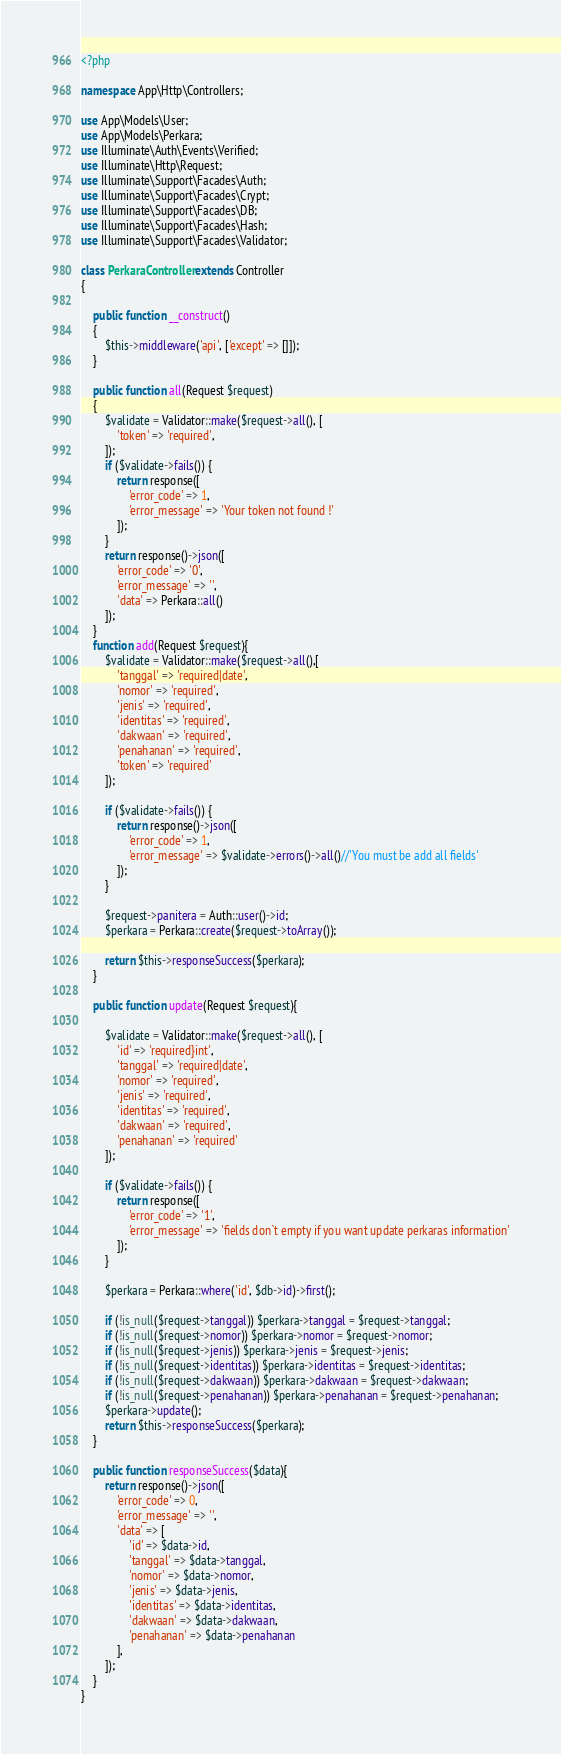Convert code to text. <code><loc_0><loc_0><loc_500><loc_500><_PHP_><?php

namespace App\Http\Controllers;

use App\Models\User;
use App\Models\Perkara;
use Illuminate\Auth\Events\Verified;
use Illuminate\Http\Request;
use Illuminate\Support\Facades\Auth;
use Illuminate\Support\Facades\Crypt;
use Illuminate\Support\Facades\DB;
use Illuminate\Support\Facades\Hash;
use Illuminate\Support\Facades\Validator;

class PerkaraController extends Controller
{
    
    public function __construct()
    {
        $this->middleware('api', ['except' => []]);
    }

    public function all(Request $request)
    {
        $validate = Validator::make($request->all(), [
            'token' => 'required',
        ]);
        if ($validate->fails()) {
            return response([
                'error_code' => 1,
                'error_message' => 'Your token not found !'
            ]);
        }
        return response()->json([
            'error_code' => '0',
            'error_message' => '',
            'data' => Perkara::all()
        ]);
    }
    function add(Request $request){
        $validate = Validator::make($request->all(),[
            'tanggal' => 'required|date',
            'nomor' => 'required',    
            'jenis' => 'required',
            'identitas' => 'required',
            'dakwaan' => 'required',
            'penahanan' => 'required',
            'token' => 'required'
        ]);

        if ($validate->fails()) {
            return response()->json([
                'error_code' => 1,
                'error_message' => $validate->errors()->all()//'You must be add all fields'
            ]);
        }

        $request->panitera = Auth::user()->id;
        $perkara = Perkara::create($request->toArray());

        return $this->responseSuccess($perkara);
    }

    public function update(Request $request){

        $validate = Validator::make($request->all(), [
            'id' => 'required}int',
            'tanggal' => 'required|date',
            'nomor' => 'required',
            'jenis' => 'required',
            'identitas' => 'required',
            'dakwaan' => 'required',
            'penahanan' => 'required'
        ]);

        if ($validate->fails()) {
            return response([
                'error_code' => '1',
                'error_message' => 'fields don`t empty if you want update perkaras information'
            ]);
        }

        $perkara = Perkara::where('id', $db->id)->first();
        
        if (!is_null($request->tanggal)) $perkara->tanggal = $request->tanggal;
        if (!is_null($request->nomor)) $perkara->nomor = $request->nomor;
        if (!is_null($request->jenis)) $perkara->jenis = $request->jenis;
        if (!is_null($request->identitas)) $perkara->identitas = $request->identitas;
        if (!is_null($request->dakwaan)) $perkara->dakwaan = $request->dakwaan;
        if (!is_null($request->penahanan)) $perkara->penahanan = $request->penahanan;
        $perkara->update();
        return $this->responseSuccess($perkara);
    }

    public function responseSuccess($data){
        return response()->json([
            'error_code' => 0,
            'error_message' => '',
            'data' => [
                'id' => $data->id,
                'tanggal' => $data->tanggal,
                'nomor' => $data->nomor,
                'jenis' => $data->jenis,
                'identitas' => $data->identitas,
                'dakwaan' => $data->dakwaan,
                'penahanan' => $data->penahanan
            ],
        ]);
    }
}
</code> 